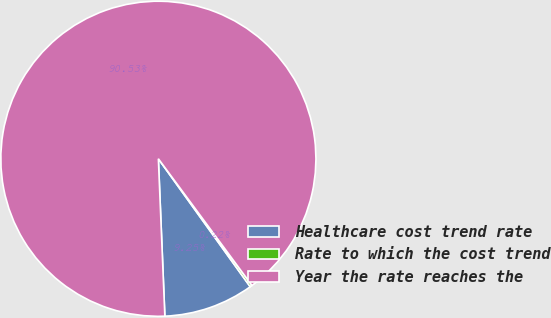<chart> <loc_0><loc_0><loc_500><loc_500><pie_chart><fcel>Healthcare cost trend rate<fcel>Rate to which the cost trend<fcel>Year the rate reaches the<nl><fcel>9.25%<fcel>0.22%<fcel>90.52%<nl></chart> 